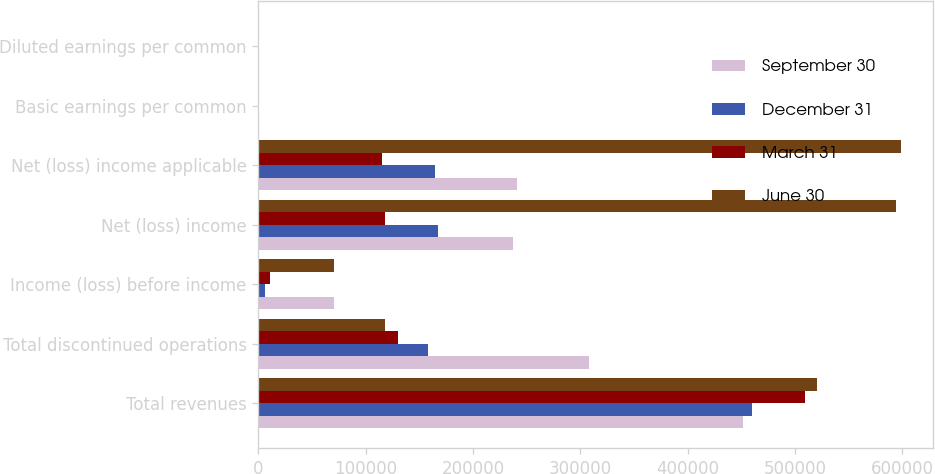Convert chart to OTSL. <chart><loc_0><loc_0><loc_500><loc_500><stacked_bar_chart><ecel><fcel>Total revenues<fcel>Total discontinued operations<fcel>Income (loss) before income<fcel>Net (loss) income<fcel>Net (loss) income applicable<fcel>Basic earnings per common<fcel>Diluted earnings per common<nl><fcel>September 30<fcel>451458<fcel>308028<fcel>70806<fcel>237503<fcel>240614<fcel>0.52<fcel>0.52<nl><fcel>December 31<fcel>459806<fcel>158479<fcel>6320<fcel>167748<fcel>164885<fcel>0.36<fcel>0.36<nl><fcel>March 31<fcel>508900<fcel>130210<fcel>11263<fcel>117954<fcel>115362<fcel>0.25<fcel>0.25<nl><fcel>June 30<fcel>520325<fcel>117954<fcel>70408<fcel>594617<fcel>598868<fcel>1.29<fcel>1.29<nl></chart> 